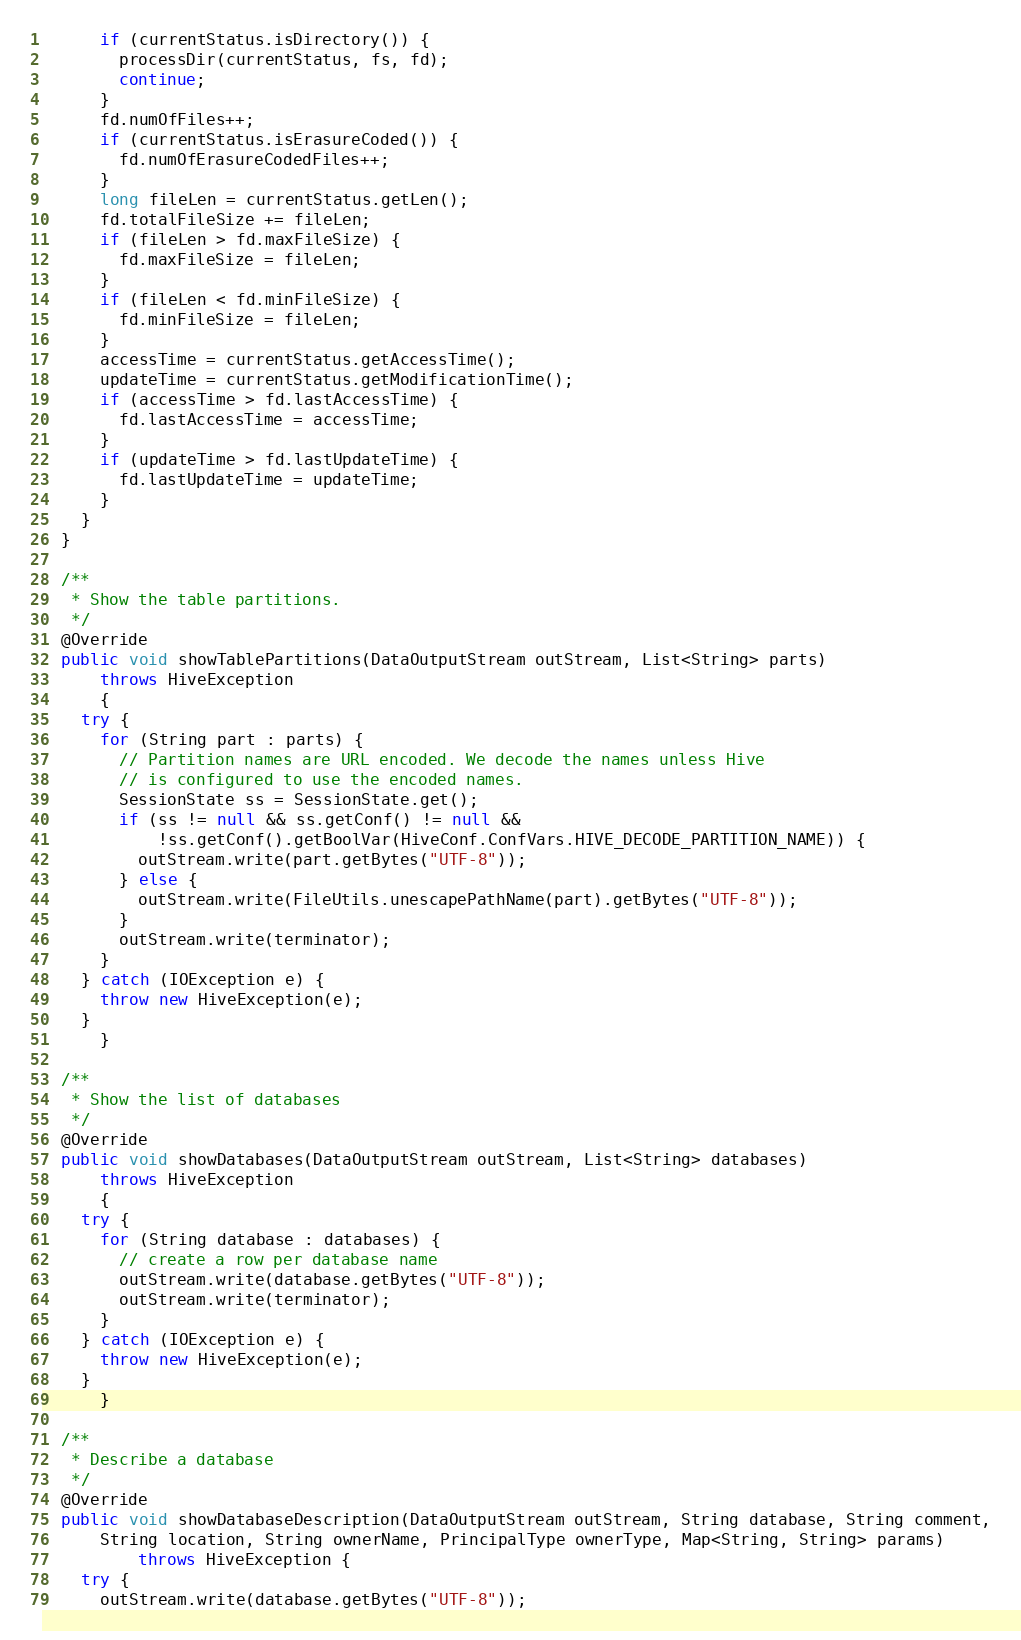Convert code to text. <code><loc_0><loc_0><loc_500><loc_500><_Java_>      if (currentStatus.isDirectory()) {
        processDir(currentStatus, fs, fd);
        continue;
      }
      fd.numOfFiles++;
      if (currentStatus.isErasureCoded()) {
        fd.numOfErasureCodedFiles++;
      }
      long fileLen = currentStatus.getLen();
      fd.totalFileSize += fileLen;
      if (fileLen > fd.maxFileSize) {
        fd.maxFileSize = fileLen;
      }
      if (fileLen < fd.minFileSize) {
        fd.minFileSize = fileLen;
      }
      accessTime = currentStatus.getAccessTime();
      updateTime = currentStatus.getModificationTime();
      if (accessTime > fd.lastAccessTime) {
        fd.lastAccessTime = accessTime;
      }
      if (updateTime > fd.lastUpdateTime) {
        fd.lastUpdateTime = updateTime;
      }
    }
  }

  /**
   * Show the table partitions.
   */
  @Override
  public void showTablePartitions(DataOutputStream outStream, List<String> parts)
      throws HiveException
      {
    try {
      for (String part : parts) {
        // Partition names are URL encoded. We decode the names unless Hive
        // is configured to use the encoded names.
        SessionState ss = SessionState.get();
        if (ss != null && ss.getConf() != null &&
            !ss.getConf().getBoolVar(HiveConf.ConfVars.HIVE_DECODE_PARTITION_NAME)) {
          outStream.write(part.getBytes("UTF-8"));
        } else {
          outStream.write(FileUtils.unescapePathName(part).getBytes("UTF-8"));
        }
        outStream.write(terminator);
      }
    } catch (IOException e) {
      throw new HiveException(e);
    }
      }

  /**
   * Show the list of databases
   */
  @Override
  public void showDatabases(DataOutputStream outStream, List<String> databases)
      throws HiveException
      {
    try {
      for (String database : databases) {
        // create a row per database name
        outStream.write(database.getBytes("UTF-8"));
        outStream.write(terminator);
      }
    } catch (IOException e) {
      throw new HiveException(e);
    }
      }

  /**
   * Describe a database
   */
  @Override
  public void showDatabaseDescription(DataOutputStream outStream, String database, String comment,
      String location, String ownerName, PrincipalType ownerType, Map<String, String> params)
          throws HiveException {
    try {
      outStream.write(database.getBytes("UTF-8"));</code> 